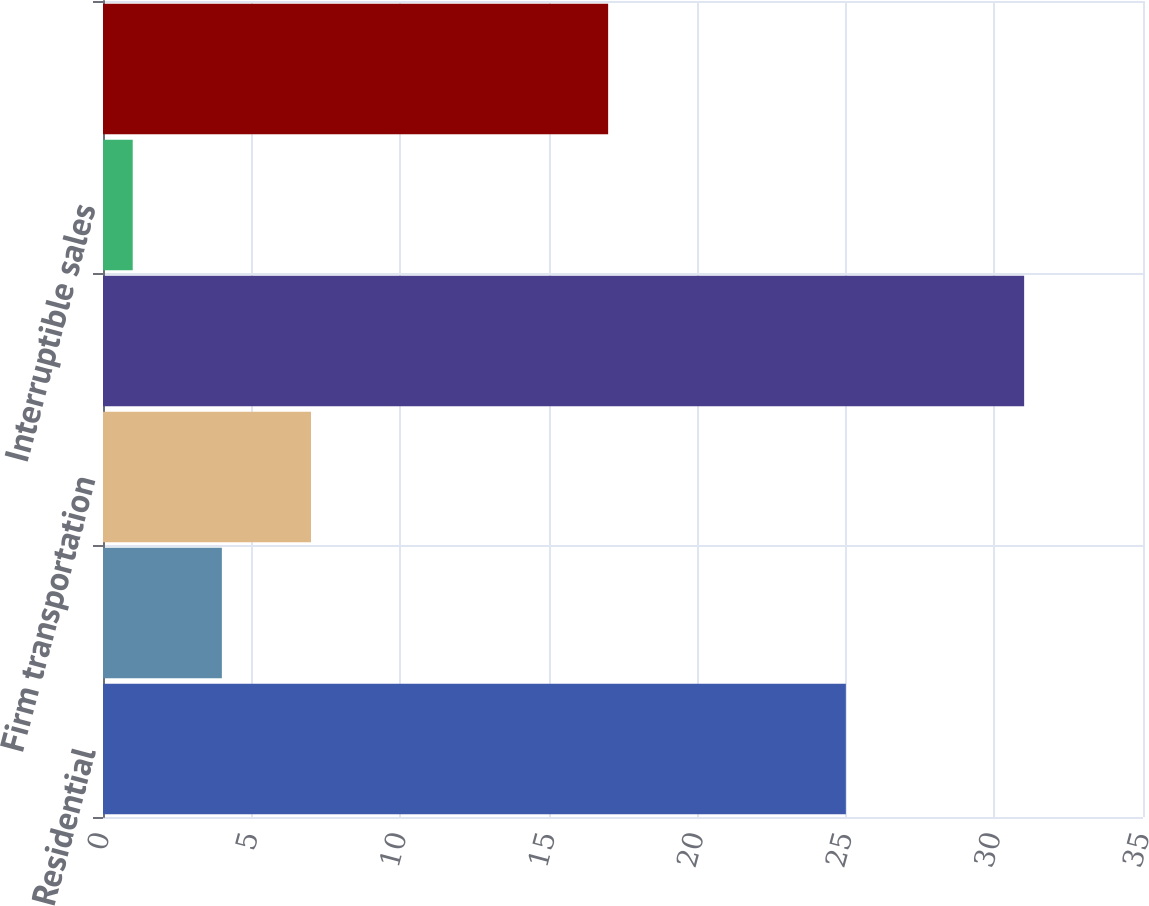Convert chart. <chart><loc_0><loc_0><loc_500><loc_500><bar_chart><fcel>Residential<fcel>General<fcel>Firm transportation<fcel>Total firm sales and<fcel>Interruptible sales<fcel>Total<nl><fcel>25<fcel>4<fcel>7<fcel>31<fcel>1<fcel>17<nl></chart> 